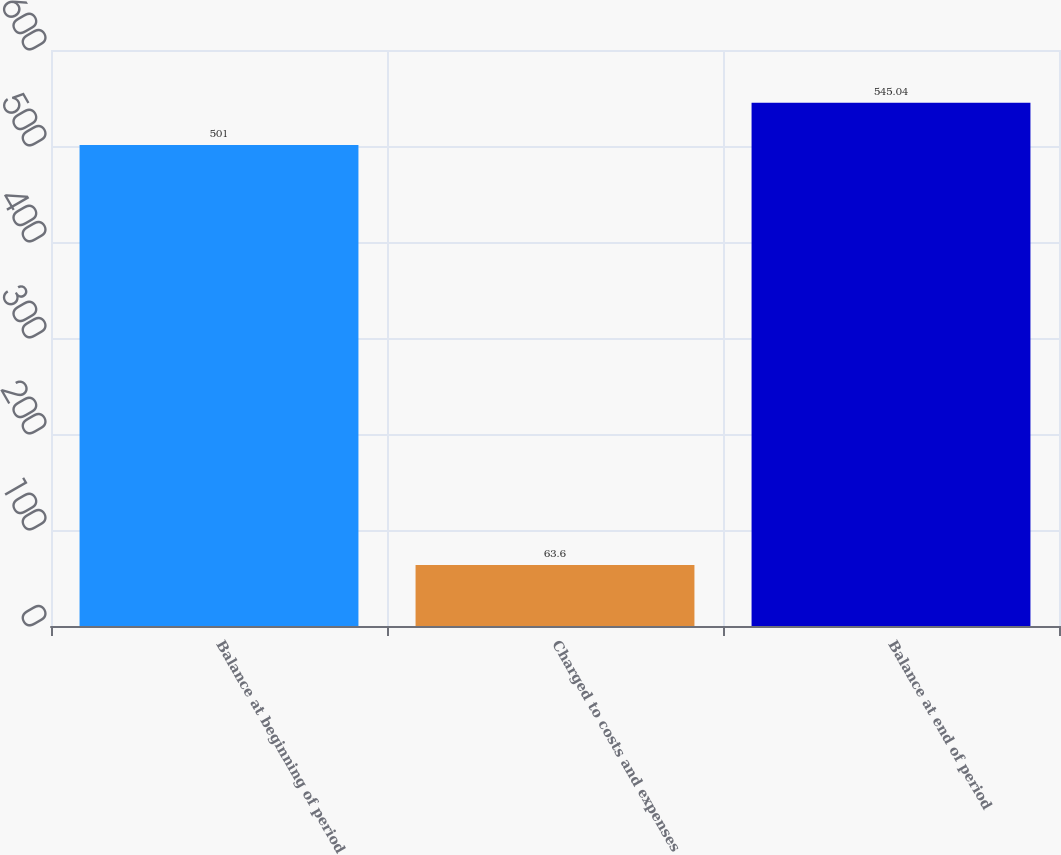<chart> <loc_0><loc_0><loc_500><loc_500><bar_chart><fcel>Balance at beginning of period<fcel>Charged to costs and expenses<fcel>Balance at end of period<nl><fcel>501<fcel>63.6<fcel>545.04<nl></chart> 